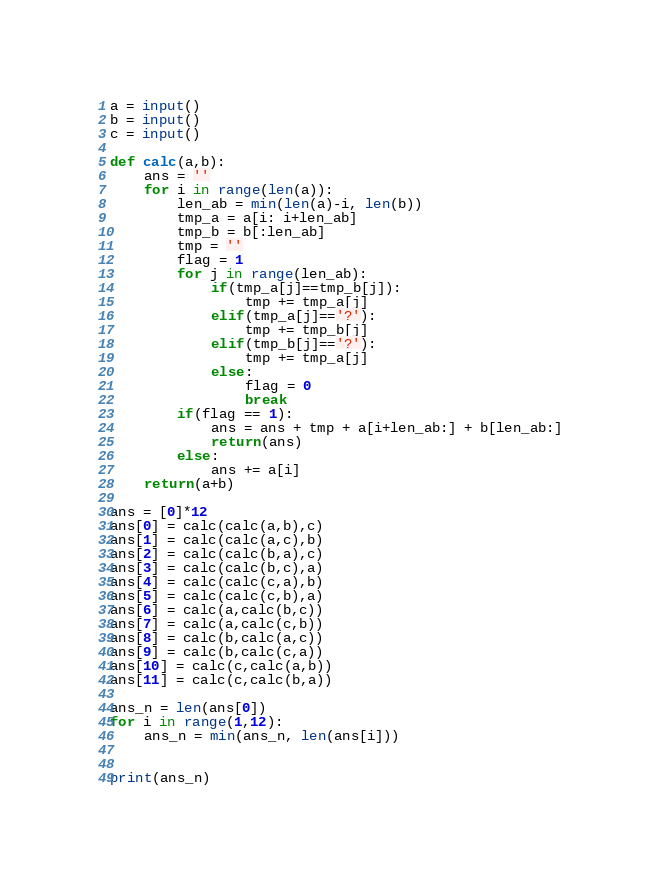Convert code to text. <code><loc_0><loc_0><loc_500><loc_500><_Python_>a = input()
b = input()
c = input()

def calc(a,b):
    ans = ''
    for i in range(len(a)):
        len_ab = min(len(a)-i, len(b))
        tmp_a = a[i: i+len_ab]
        tmp_b = b[:len_ab]
        tmp = ''
        flag = 1
        for j in range(len_ab):
            if(tmp_a[j]==tmp_b[j]):
                tmp += tmp_a[j]
            elif(tmp_a[j]=='?'):
                tmp += tmp_b[j]
            elif(tmp_b[j]=='?'):
                tmp += tmp_a[j]
            else:
                flag = 0
                break
        if(flag == 1):
            ans = ans + tmp + a[i+len_ab:] + b[len_ab:]
            return(ans)
        else:
            ans += a[i]
    return(a+b)

ans = [0]*12
ans[0] = calc(calc(a,b),c)
ans[1] = calc(calc(a,c),b)
ans[2] = calc(calc(b,a),c)
ans[3] = calc(calc(b,c),a)
ans[4] = calc(calc(c,a),b)
ans[5] = calc(calc(c,b),a)
ans[6] = calc(a,calc(b,c))
ans[7] = calc(a,calc(c,b))
ans[8] = calc(b,calc(a,c))
ans[9] = calc(b,calc(c,a))
ans[10] = calc(c,calc(a,b))
ans[11] = calc(c,calc(b,a))

ans_n = len(ans[0])
for i in range(1,12):
    ans_n = min(ans_n, len(ans[i]))


print(ans_n)</code> 